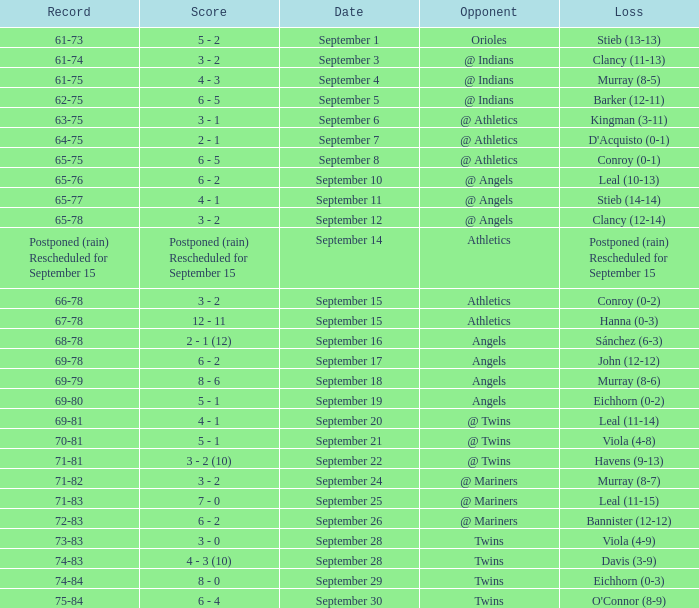Name the score for september 11 4 - 1. 